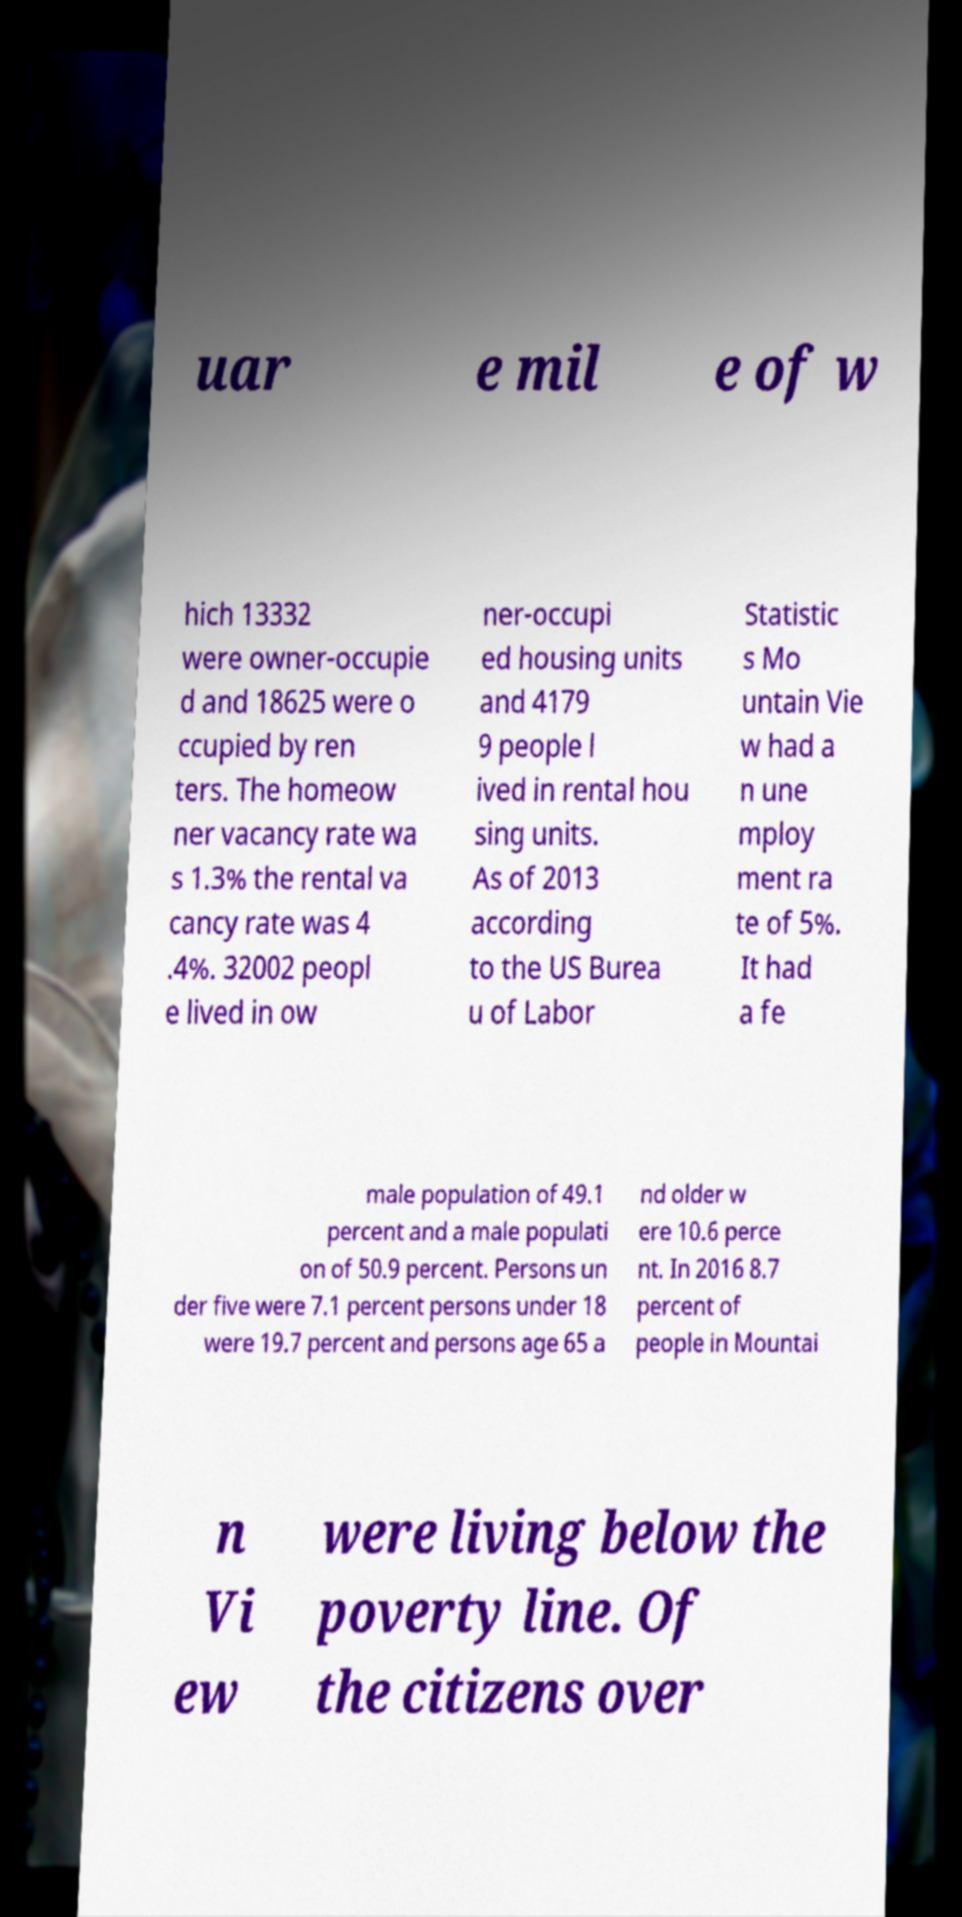Please read and relay the text visible in this image. What does it say? uar e mil e of w hich 13332 were owner-occupie d and 18625 were o ccupied by ren ters. The homeow ner vacancy rate wa s 1.3% the rental va cancy rate was 4 .4%. 32002 peopl e lived in ow ner-occupi ed housing units and 4179 9 people l ived in rental hou sing units. As of 2013 according to the US Burea u of Labor Statistic s Mo untain Vie w had a n une mploy ment ra te of 5%. It had a fe male population of 49.1 percent and a male populati on of 50.9 percent. Persons un der five were 7.1 percent persons under 18 were 19.7 percent and persons age 65 a nd older w ere 10.6 perce nt. In 2016 8.7 percent of people in Mountai n Vi ew were living below the poverty line. Of the citizens over 